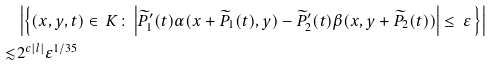Convert formula to latex. <formula><loc_0><loc_0><loc_500><loc_500>& \left | \left \{ ( x , y , t ) \in \, K \colon \left | \widetilde { P } _ { 1 } ^ { \prime } ( t ) \alpha ( x + \widetilde { P } _ { 1 } ( t ) , y ) - \widetilde { P } _ { 2 } ^ { \prime } ( t ) \beta ( x , y + \widetilde { P } _ { 2 } ( t ) ) \right | \leq \, \varepsilon \, \right \} \right | \\ \lesssim & 2 ^ { c | l | } \varepsilon ^ { 1 / 3 5 }</formula> 